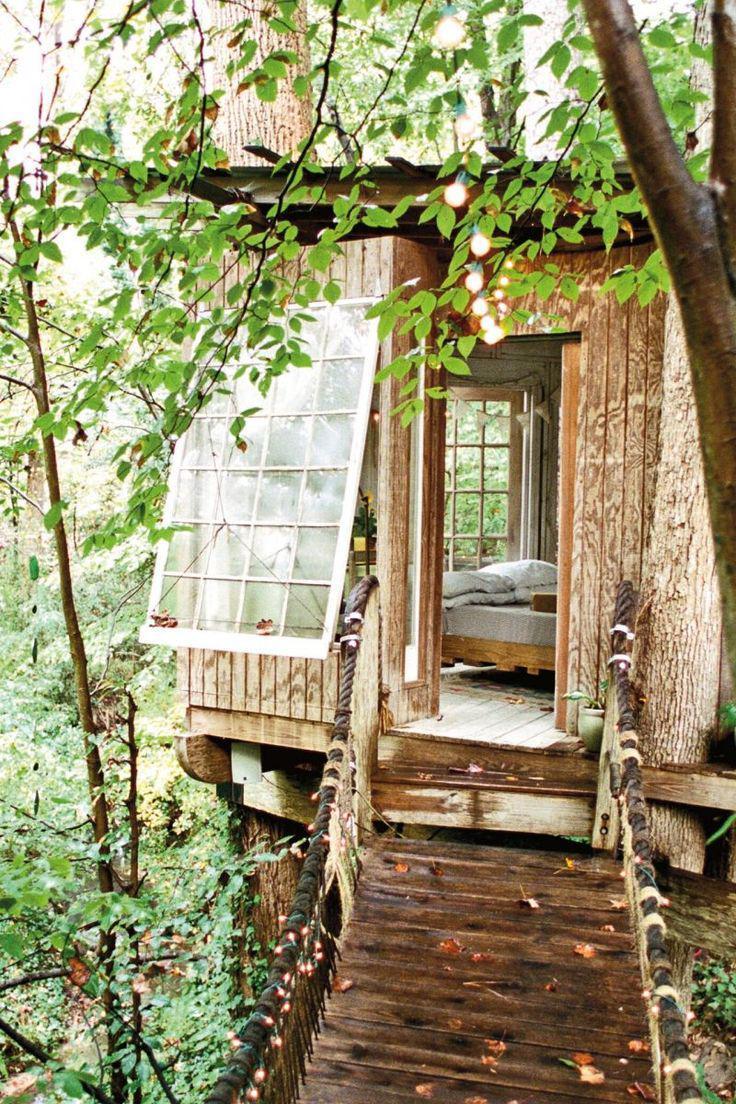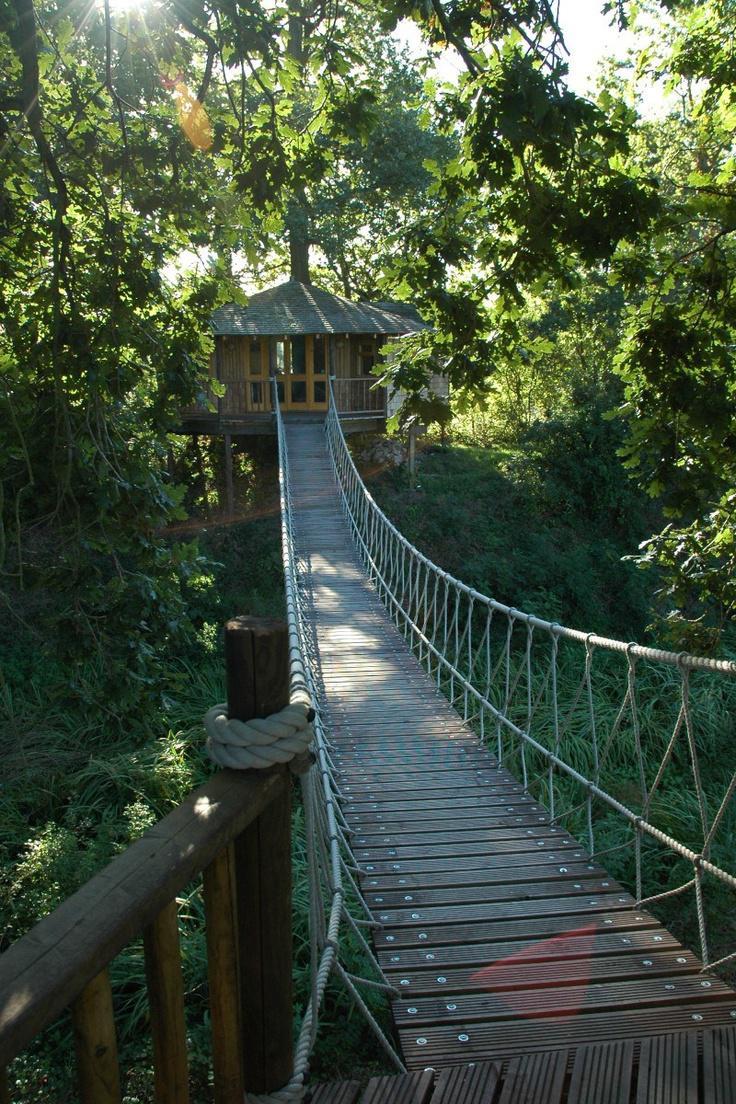The first image is the image on the left, the second image is the image on the right. Given the left and right images, does the statement "there is a tree house with a bridge leading to it, in front of the house there are two tree trunks and there is one trunk behind" hold true? Answer yes or no. No. The first image is the image on the left, the second image is the image on the right. Examine the images to the left and right. Is the description "A rope walkway leads from the lower left to an elevated treehouse surrounded by a deck with railing." accurate? Answer yes or no. No. 